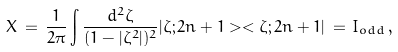Convert formula to latex. <formula><loc_0><loc_0><loc_500><loc_500>X \, = \, \frac { 1 } { 2 \pi } \int \frac { d ^ { 2 } { \zeta } } { ( 1 - | { \zeta } ^ { 2 } | ) ^ { 2 } } | \zeta ; 2 n + 1 > < \zeta ; 2 n + 1 | \, = \, I _ { o d d } \, ,</formula> 